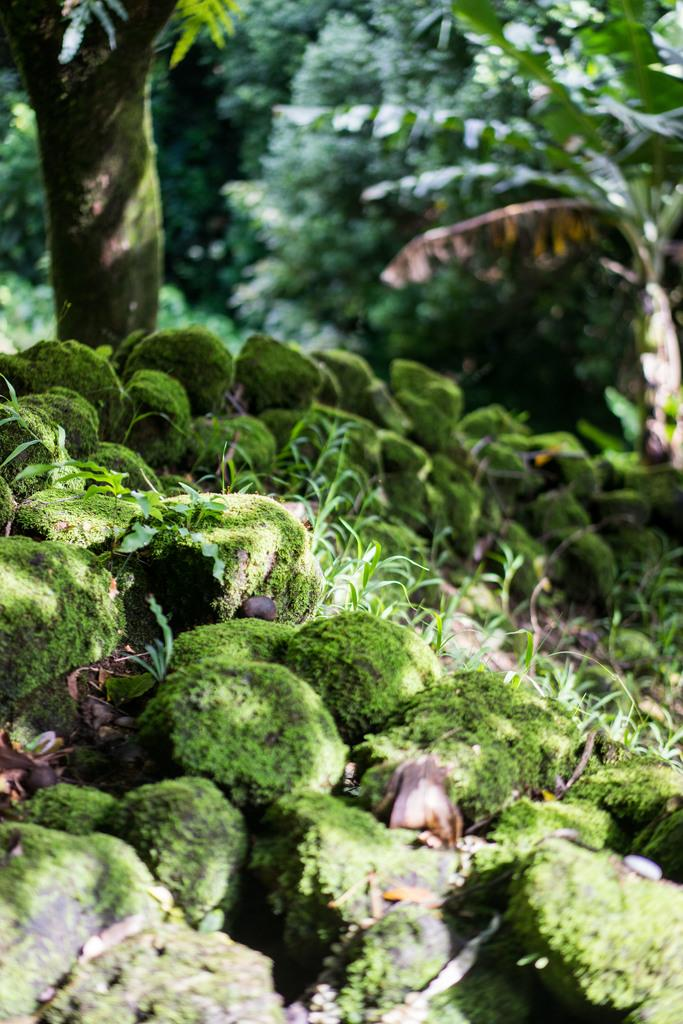What type of vegetation can be seen in the image? There are trees, plants, and grass visible in the image. What other elements can be found in the image? There are stones in the image. Where is the party being held in the image? There is no party present in the image; it features trees, plants, grass, and stones. What type of good-bye gesture can be seen in the image? There is no good-bye gesture present in the image. 